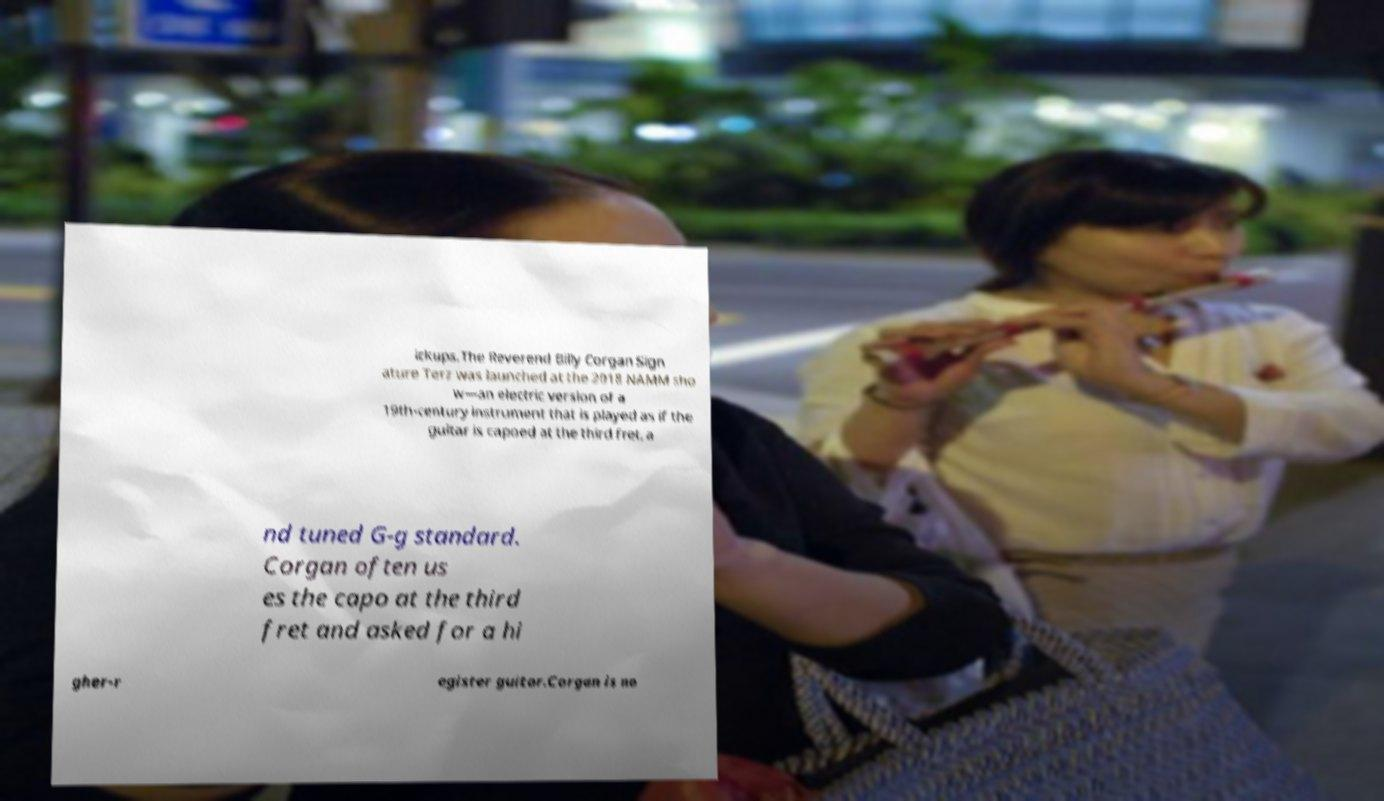Can you read and provide the text displayed in the image?This photo seems to have some interesting text. Can you extract and type it out for me? ickups.The Reverend Billy Corgan Sign ature Terz was launched at the 2018 NAMM sho w—an electric version of a 19th-century instrument that is played as if the guitar is capoed at the third fret, a nd tuned G-g standard. Corgan often us es the capo at the third fret and asked for a hi gher-r egister guitar.Corgan is no 